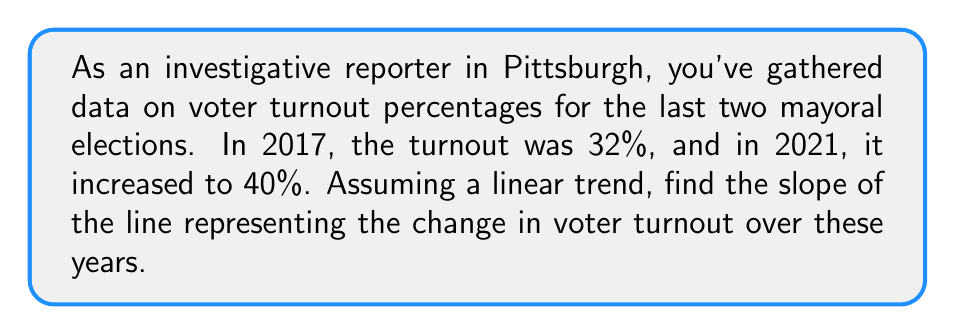Provide a solution to this math problem. To find the slope of the line representing voter turnout trends, we'll use the slope formula:

$$ m = \frac{y_2 - y_1}{x_2 - x_1} $$

Where:
- $(x_1, y_1)$ is the first point (2017, 32%)
- $(x_2, y_2)$ is the second point (2021, 40%)

Step 1: Identify the coordinates
- $(x_1, y_1) = (2017, 32)$
- $(x_2, y_2) = (2021, 40)$

Step 2: Calculate the change in y (voter turnout percentage)
$y_2 - y_1 = 40 - 32 = 8$

Step 3: Calculate the change in x (years)
$x_2 - x_1 = 2021 - 2017 = 4$

Step 4: Apply the slope formula
$$ m = \frac{y_2 - y_1}{x_2 - x_1} = \frac{8}{4} = 2 $$

The slope is 2, which means the voter turnout is increasing by 2 percentage points per year.
Answer: $2$ percentage points per year 